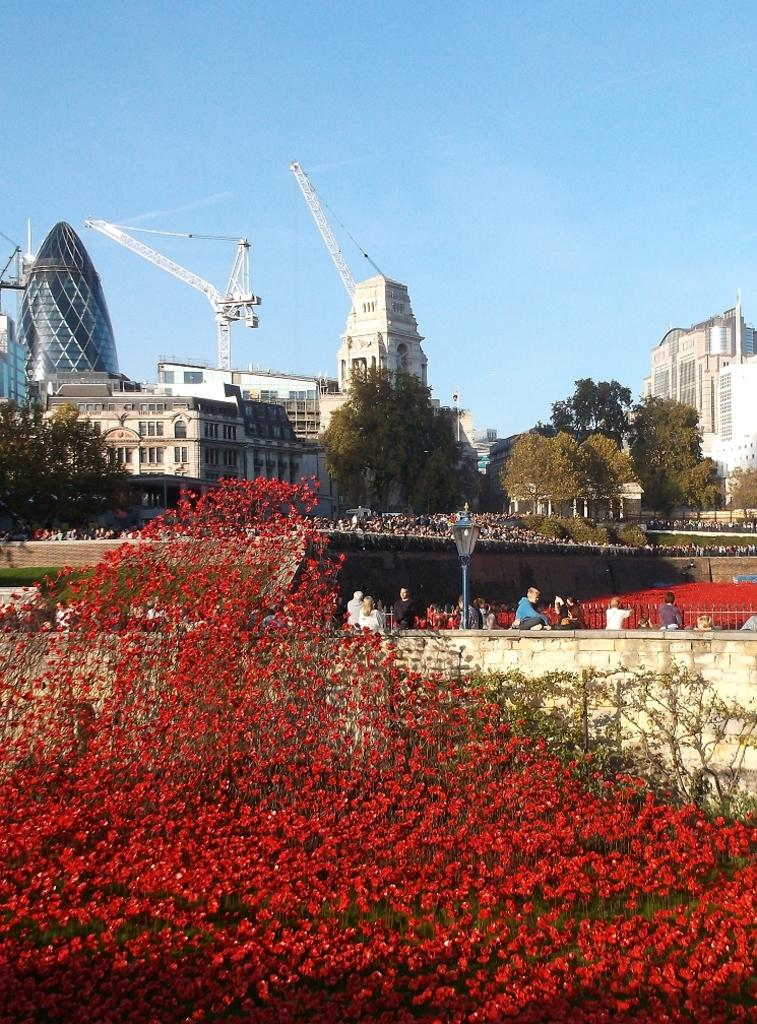What type of flowers can be seen in the foreground of the image? There are red color flowers in the foreground of the image. Where are the flowers located on? The flowers are on a plant. What can be seen in the background of the image? There is a wall, a railing, a pole, a crowd, buildings, trees, and the sky visible in the background of the image. What type of knee injury can be seen in the image? There is no knee injury present in the image; it features flowers, a plant, and various elements in the background. 